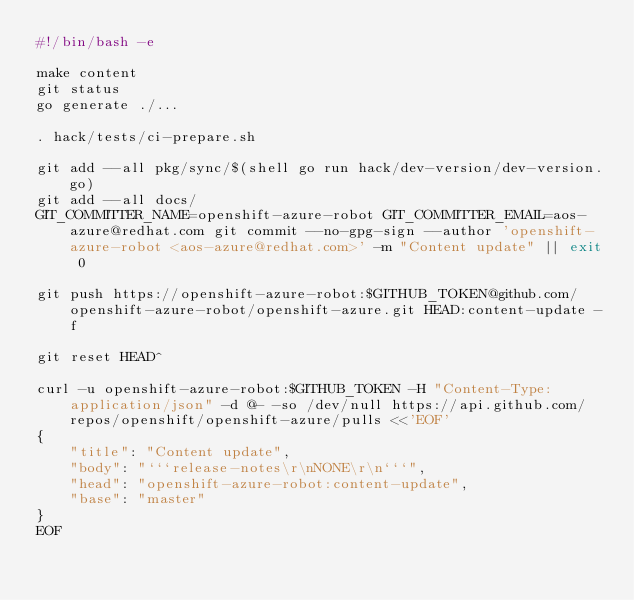<code> <loc_0><loc_0><loc_500><loc_500><_Bash_>#!/bin/bash -e

make content
git status
go generate ./...

. hack/tests/ci-prepare.sh

git add --all pkg/sync/$(shell go run hack/dev-version/dev-version.go)
git add --all docs/
GIT_COMMITTER_NAME=openshift-azure-robot GIT_COMMITTER_EMAIL=aos-azure@redhat.com git commit --no-gpg-sign --author 'openshift-azure-robot <aos-azure@redhat.com>' -m "Content update" || exit 0

git push https://openshift-azure-robot:$GITHUB_TOKEN@github.com/openshift-azure-robot/openshift-azure.git HEAD:content-update -f

git reset HEAD^

curl -u openshift-azure-robot:$GITHUB_TOKEN -H "Content-Type:application/json" -d @- -so /dev/null https://api.github.com/repos/openshift/openshift-azure/pulls <<'EOF'
{
    "title": "Content update",
    "body": "```release-notes\r\nNONE\r\n```",
    "head": "openshift-azure-robot:content-update",
    "base": "master"
}
EOF
</code> 